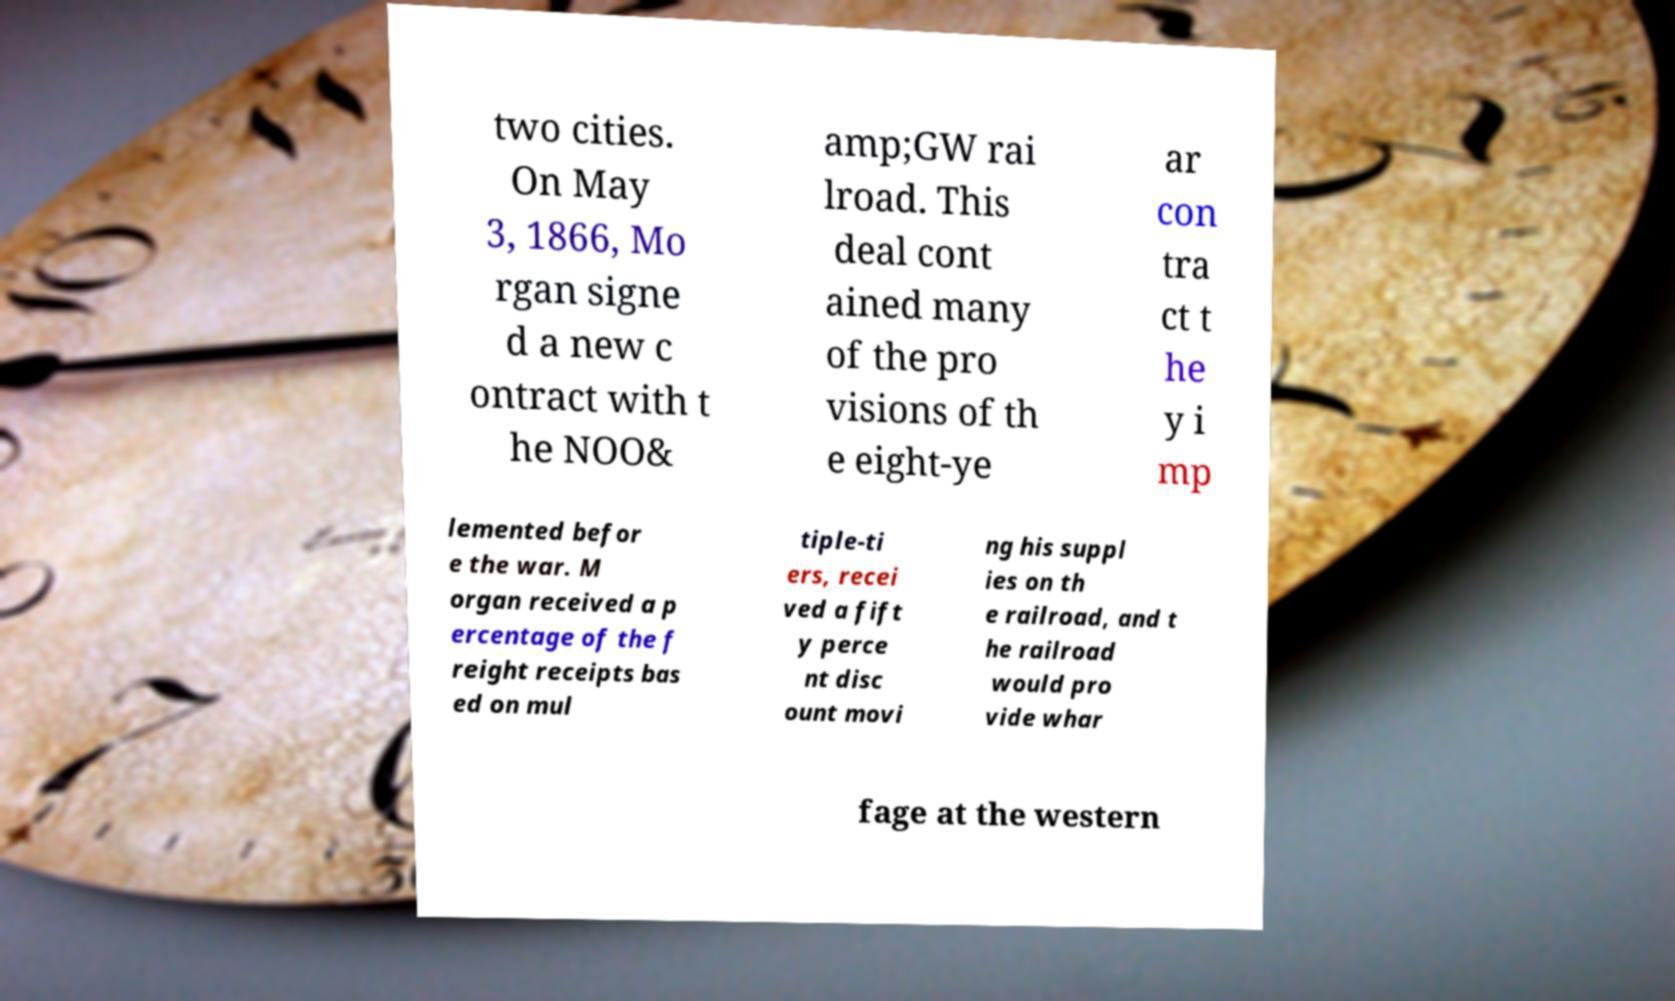Can you accurately transcribe the text from the provided image for me? two cities. On May 3, 1866, Mo rgan signe d a new c ontract with t he NOO& amp;GW rai lroad. This deal cont ained many of the pro visions of th e eight-ye ar con tra ct t he y i mp lemented befor e the war. M organ received a p ercentage of the f reight receipts bas ed on mul tiple-ti ers, recei ved a fift y perce nt disc ount movi ng his suppl ies on th e railroad, and t he railroad would pro vide whar fage at the western 